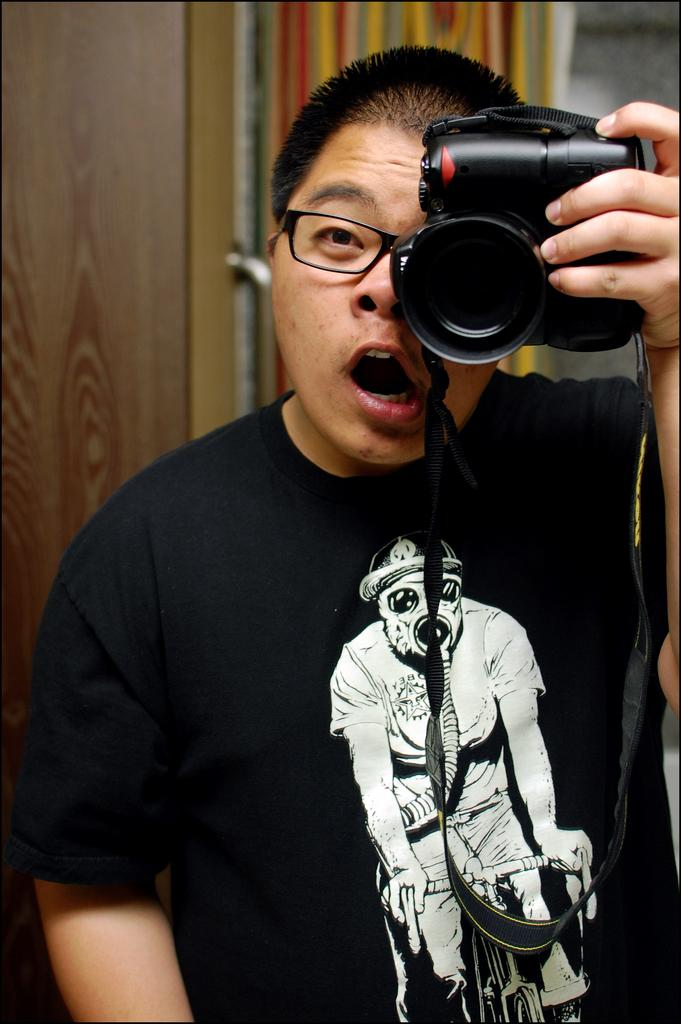Who is present in the image? There is a man in the image. What is the man wearing? The man is wearing a black T-shirt. What is the man holding in his hand? The man is holding a camera in his hand. What can be seen in the background of the image? There is a door in the background of the image. What feature is present on the door? The door has a door handle. What type of representative can be seen in the image? There is no representative present in the image. 